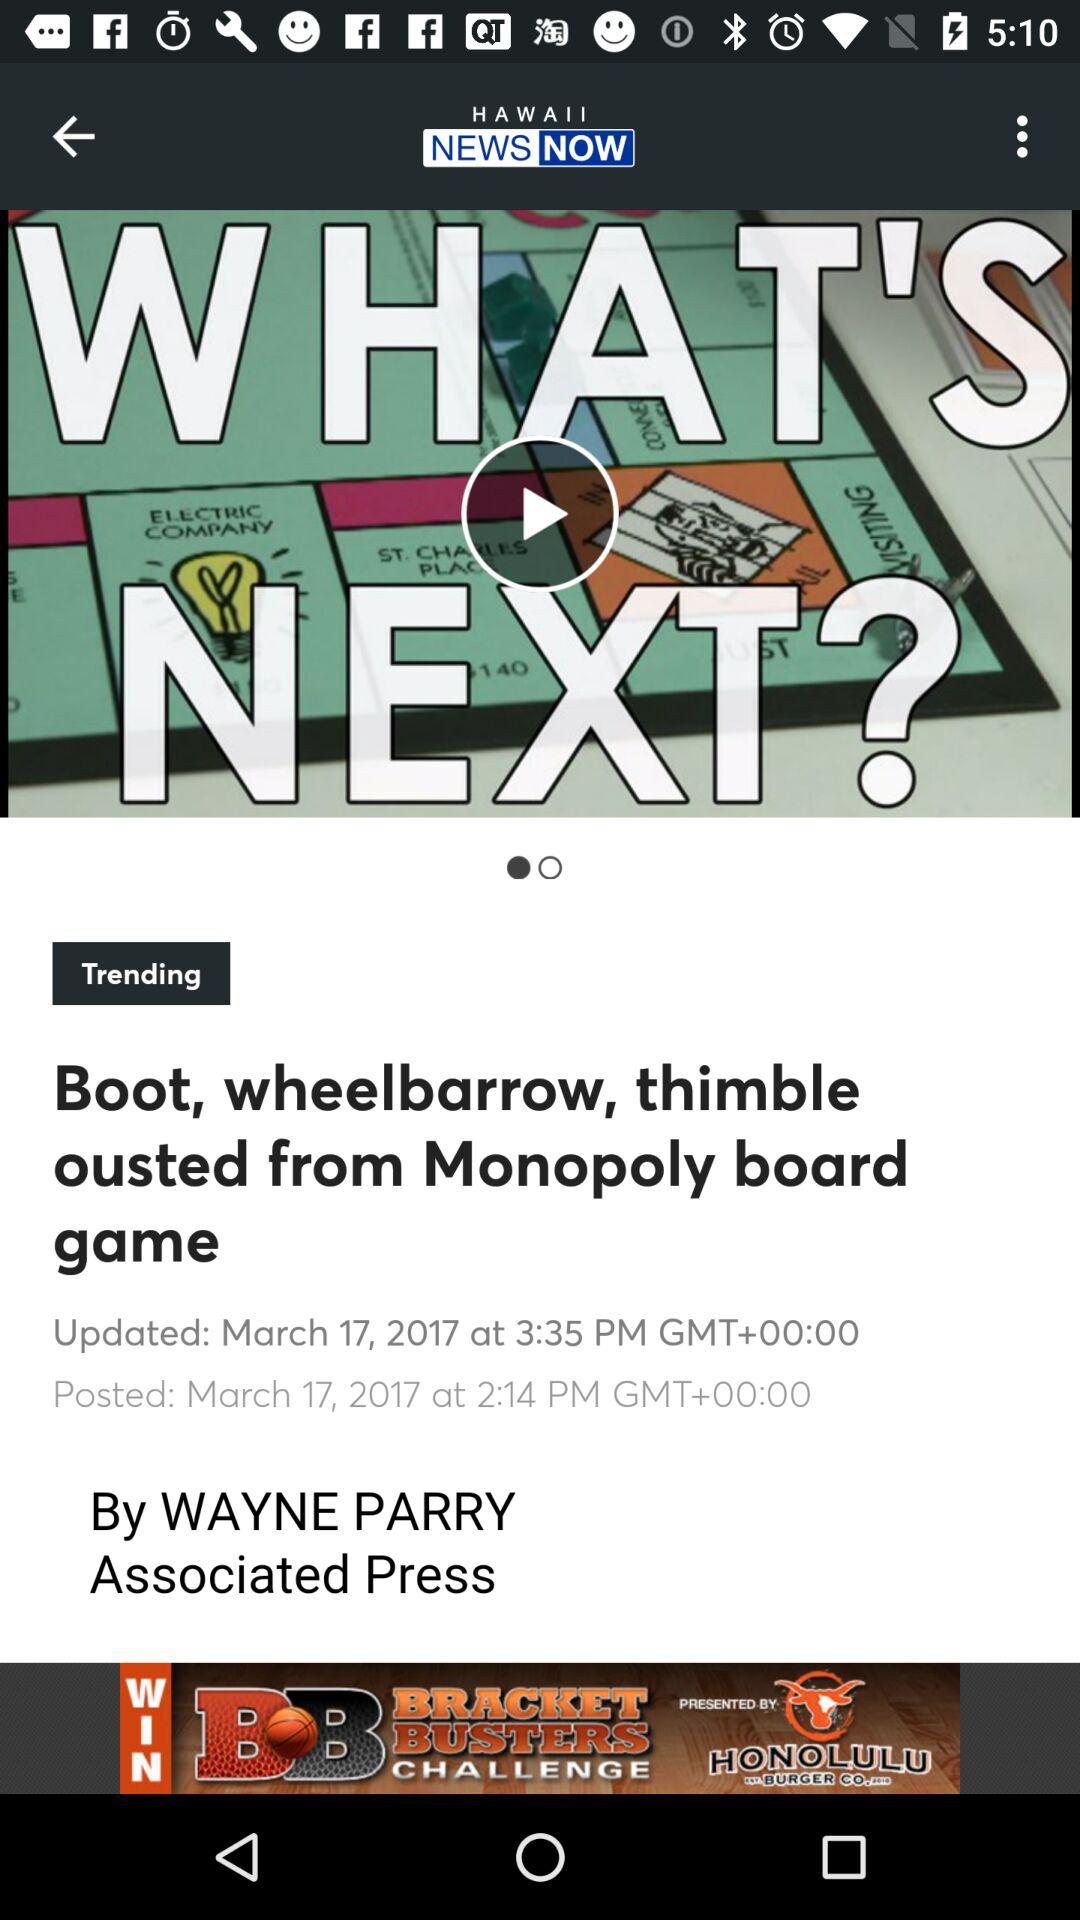Who is writer? The writer is "WAYNE PARRY". 